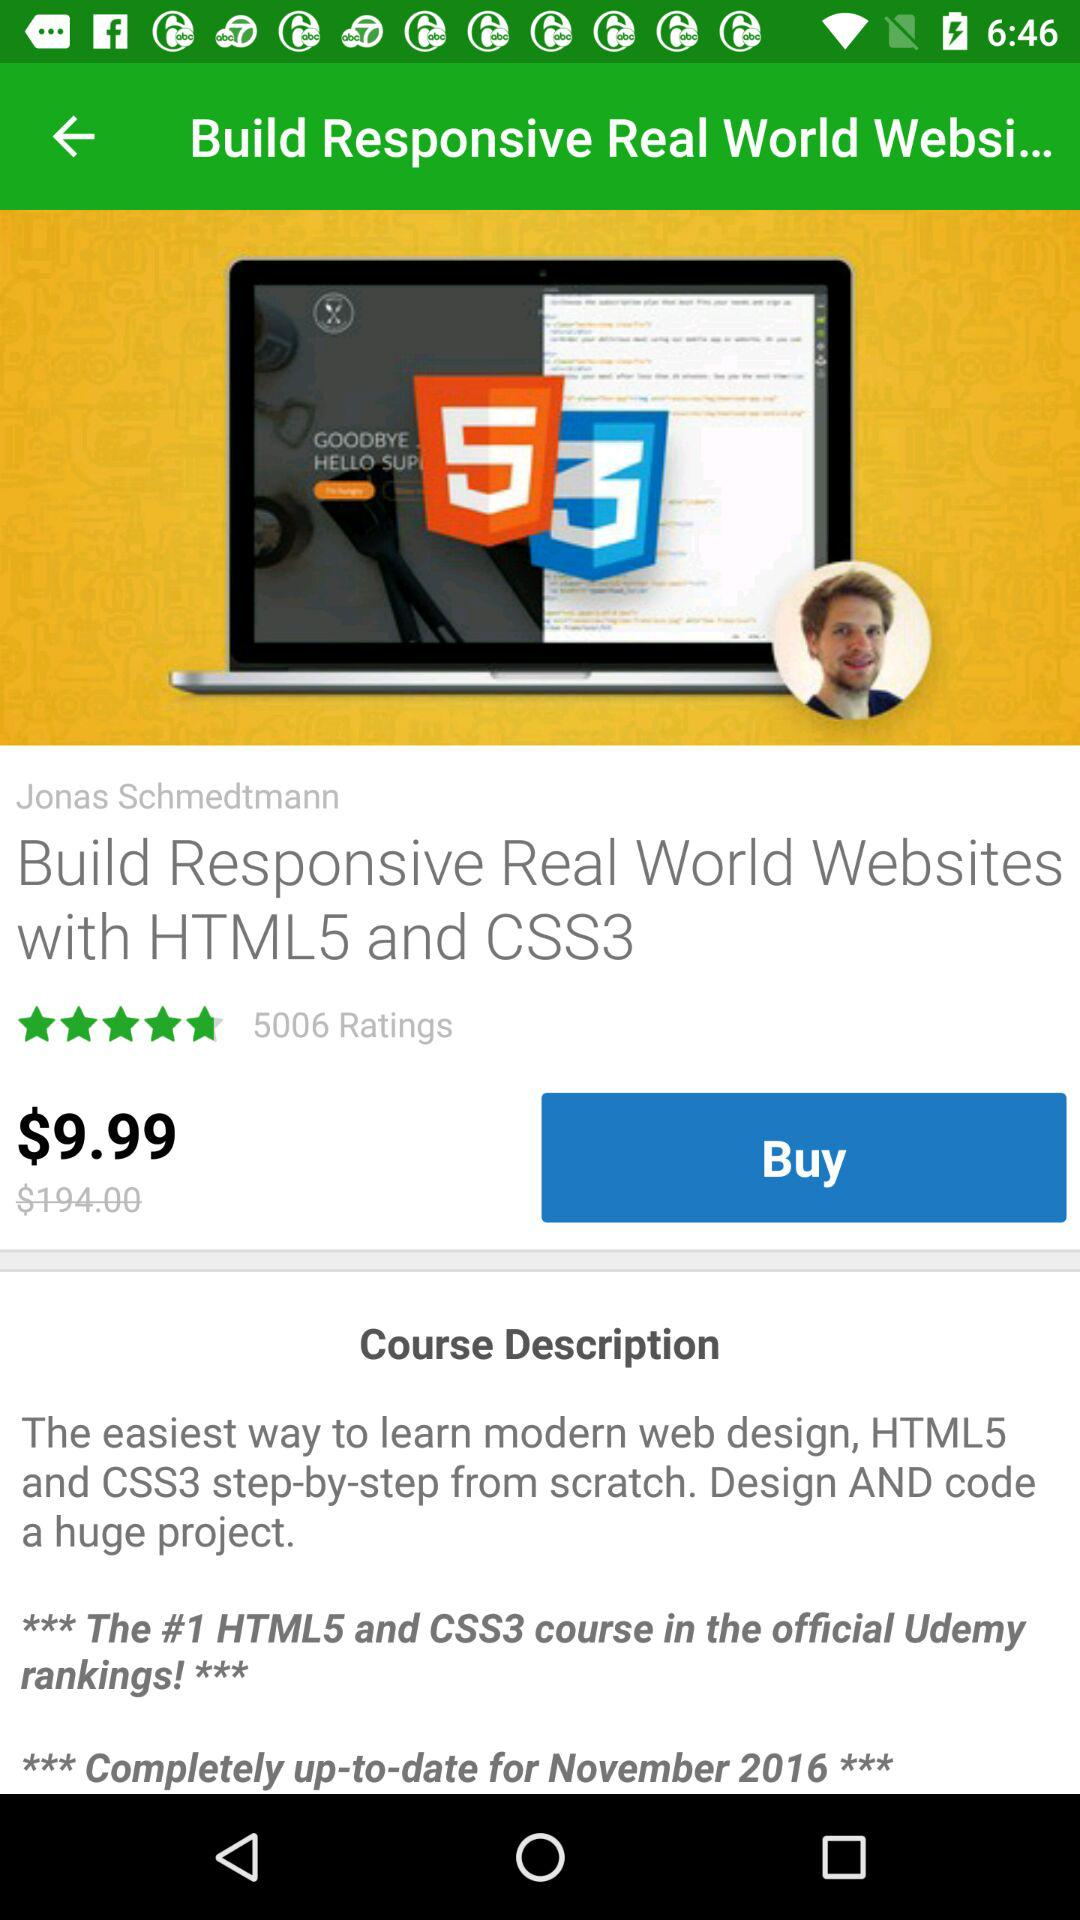What is the name of the developer?
When the provided information is insufficient, respond with <no answer>. <no answer> 